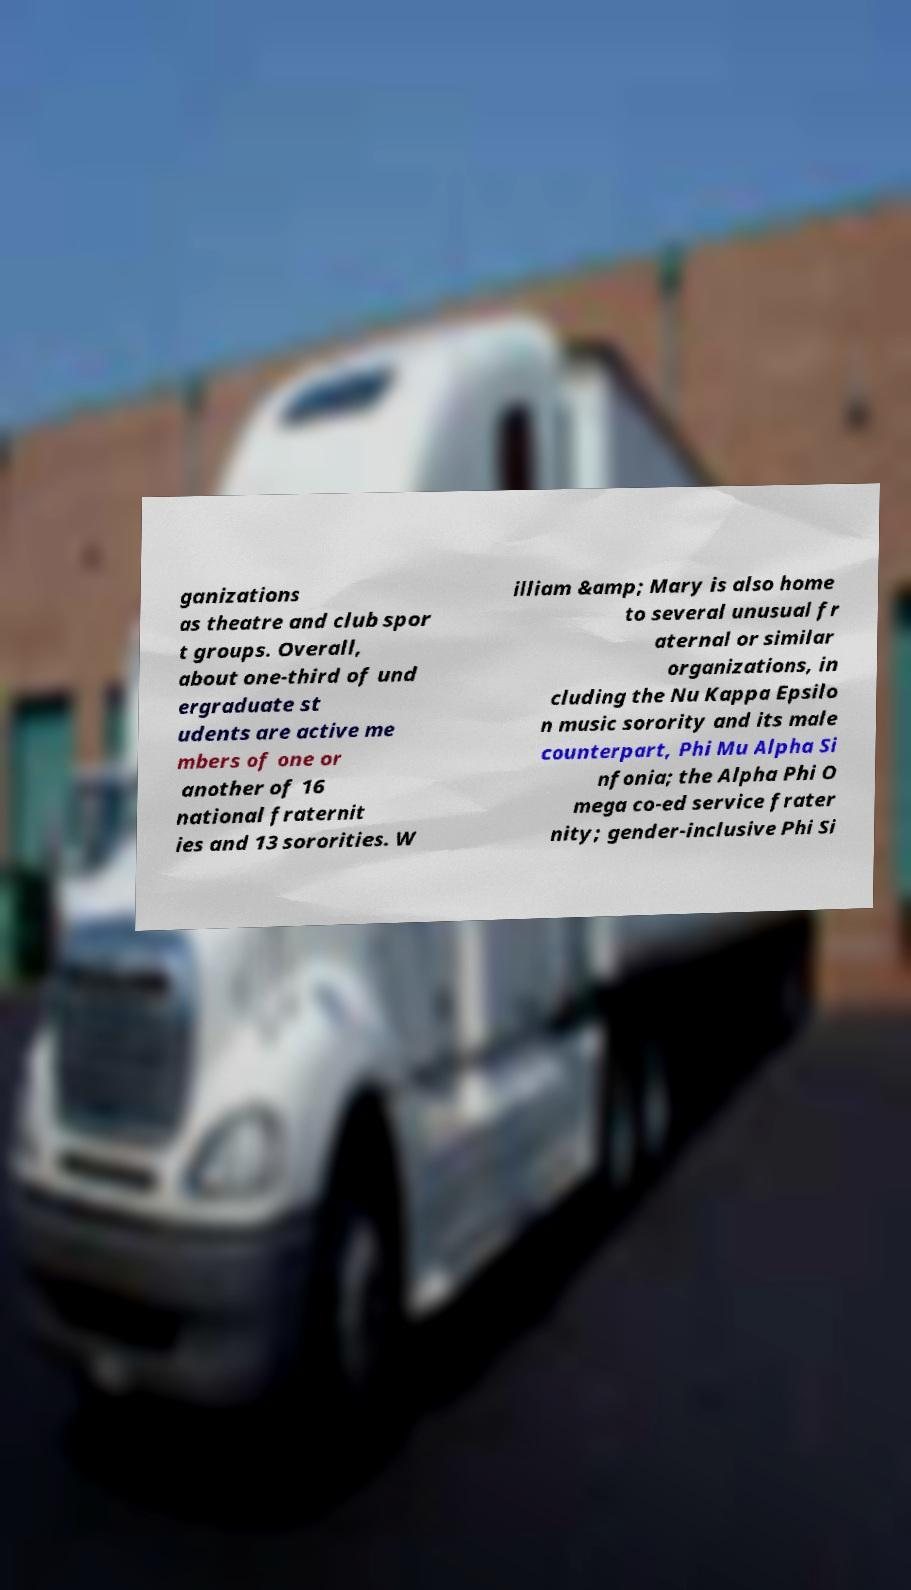For documentation purposes, I need the text within this image transcribed. Could you provide that? ganizations as theatre and club spor t groups. Overall, about one-third of und ergraduate st udents are active me mbers of one or another of 16 national fraternit ies and 13 sororities. W illiam &amp; Mary is also home to several unusual fr aternal or similar organizations, in cluding the Nu Kappa Epsilo n music sorority and its male counterpart, Phi Mu Alpha Si nfonia; the Alpha Phi O mega co-ed service frater nity; gender-inclusive Phi Si 